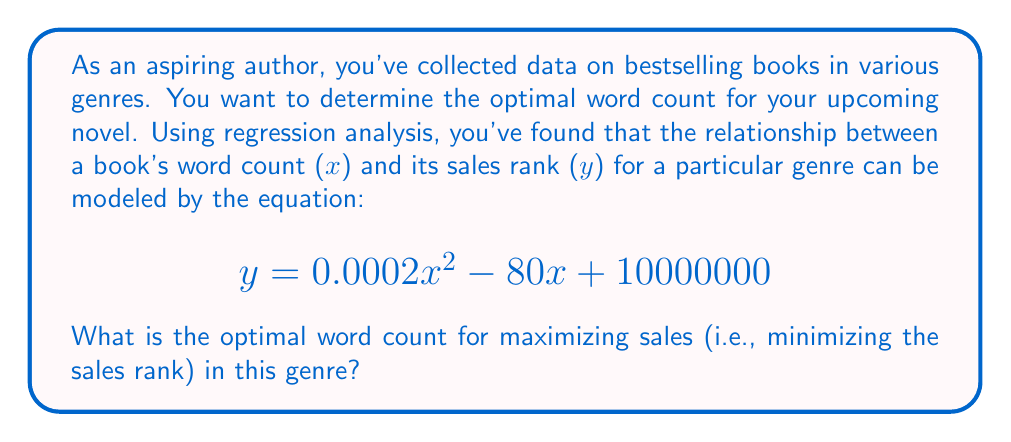Teach me how to tackle this problem. To find the optimal word count, we need to determine the minimum point of the quadratic function representing the relationship between word count and sales rank. Here's how we can do this:

1. The general form of a quadratic function is $f(x) = ax^2 + bx + c$. In our case:
   $a = 0.0002$, $b = -80$, and $c = 10000000$

2. For a quadratic function, the x-coordinate of the vertex (which represents the minimum point for a parabola that opens upward) is given by the formula:

   $$x = -\frac{b}{2a}$$

3. Let's substitute our values:

   $$x = -\frac{-80}{2(0.0002)} = \frac{80}{0.0004} = 200000$$

4. To verify this is a minimum (not a maximum), we can check that $a > 0$, which it is $(0.0002 > 0)$.

5. Therefore, the optimal word count that minimizes the sales rank (and thus maximizes sales) is 200,000 words.
Answer: The optimal word count for maximizing sales in this genre is 200,000 words. 